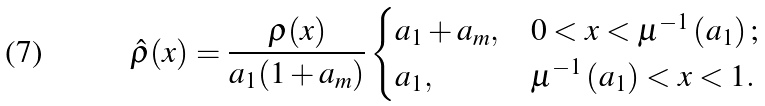Convert formula to latex. <formula><loc_0><loc_0><loc_500><loc_500>\hat { \rho } ( x ) = \frac { \rho ( x ) } { a _ { 1 } ( 1 + a _ { m } ) } \begin{cases} a _ { 1 } + a _ { m } , & 0 < x < \mu ^ { - 1 } \left ( a _ { 1 } \right ) ; \\ a _ { 1 } , & \mu ^ { - 1 } \left ( a _ { 1 } \right ) < x < 1 . \end{cases}</formula> 